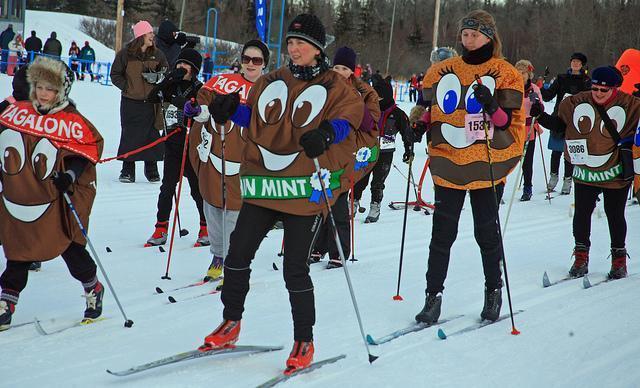How many people are in the photo?
Give a very brief answer. 10. 